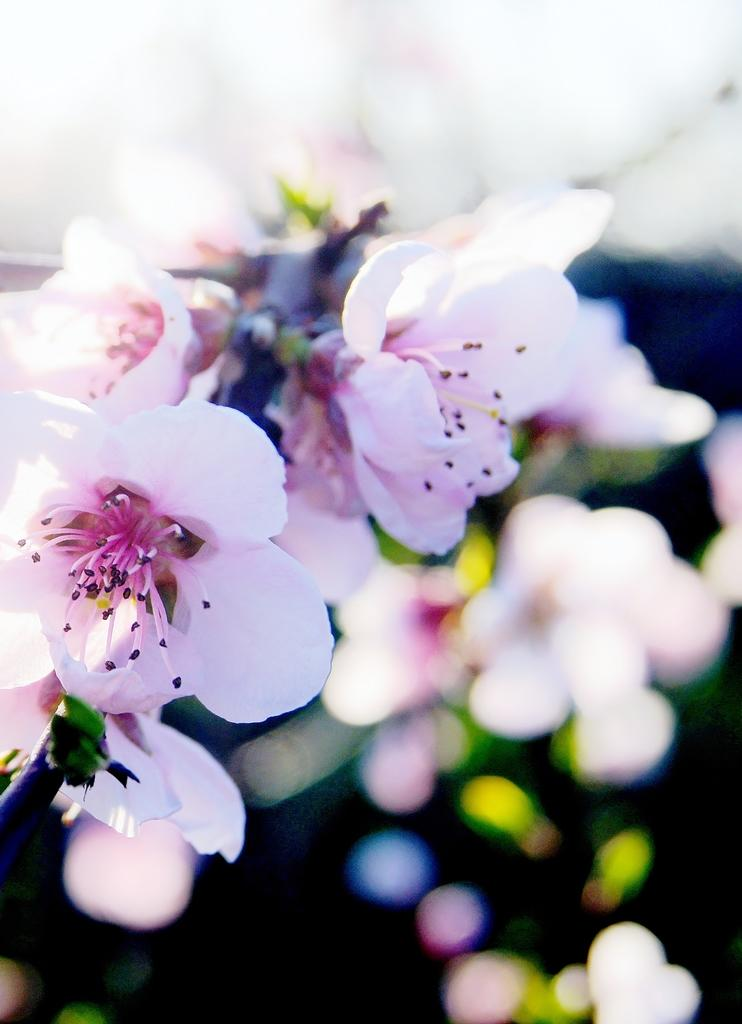What is located in the front of the image? There are flowers in the front of the image. Can you describe the background of the image? The background of the image is blurry. What type of food is being prepared in the dirt in the image? There is no food or dirt present in the image; it features flowers in the front and a blurry background. 